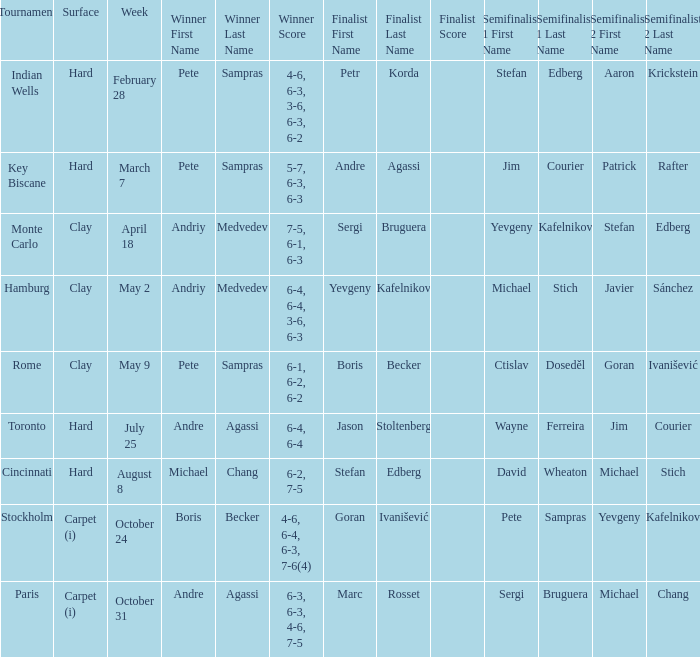Who was the semifinalist for the key biscane tournament? Jim Courier Patrick Rafter. 